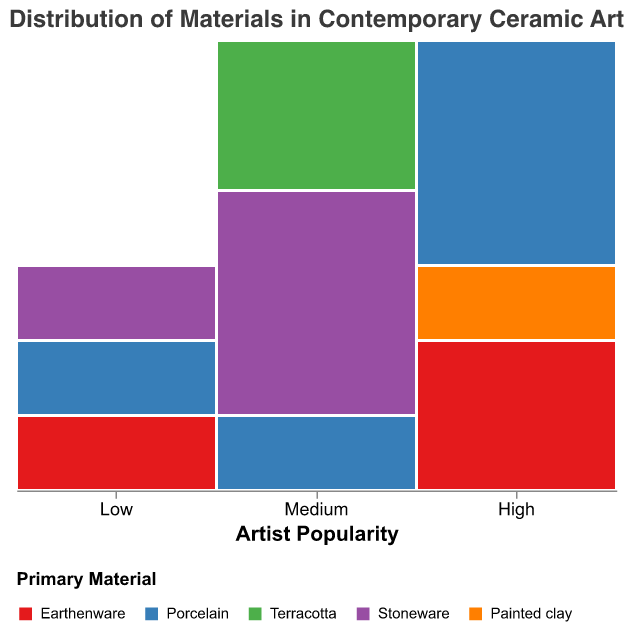What is the title of the plot? The title of the plot can be found at the top of the figure.
Answer: Distribution of Materials in Contemporary Ceramic Art Which artist popularity category uses the most Porcelain? Look at the segments of the plot that represent Porcelain in different artist popularity categories. The High popularity category has the largest proportion of Porcelain.
Answer: High How does the usage of Earthenware compare between the Low and High popularity categories? Identify the segments representing Earthenware in both the Low and High popularity categories and compare their sizes. Earthenware has a larger segment in the High category than the Low category.
Answer: Higher in High category What percentage of Medium popularity artists use Stoneware? Locate the Stoneware section in the Medium popularity column and use the tooltip or legend to find the percentage. The percentage is calculated from the total within the Medium category.
Answer: 50% How many different primary materials are used by High popularity artists? Identify and count the distinct color segments in the High popularity column.
Answer: Four Which primary material is least used by artists in the Low popularity category? Look at the segments in the Low popularity column and compare the sizes of each color. Painted clay or Terracotta, depending on precise values.
Answer: Painted clay or Terracotta What is the combined percentage of Terracotta used by Medium and Low popularity artists? Add the individual percentages of Terracotta in Medium and Low popularity columns. Medium uses Terracotta at 2/6 or 33.3%, and Low at 0%. Sum them up.
Answer: 33.3% Does the Medium popularity category use more Stoneware or Porcelain? Compare the sizes of the Stoneware and Porcelain segments in the Medium popularity column. Stoneware has a larger segment.
Answer: Stoneware Which primary material is unique to the High popularity category? Identify the materials by color in the High popularity column and compare them with materials in other categories. Painted clay is only present in the High category.
Answer: Painted clay 